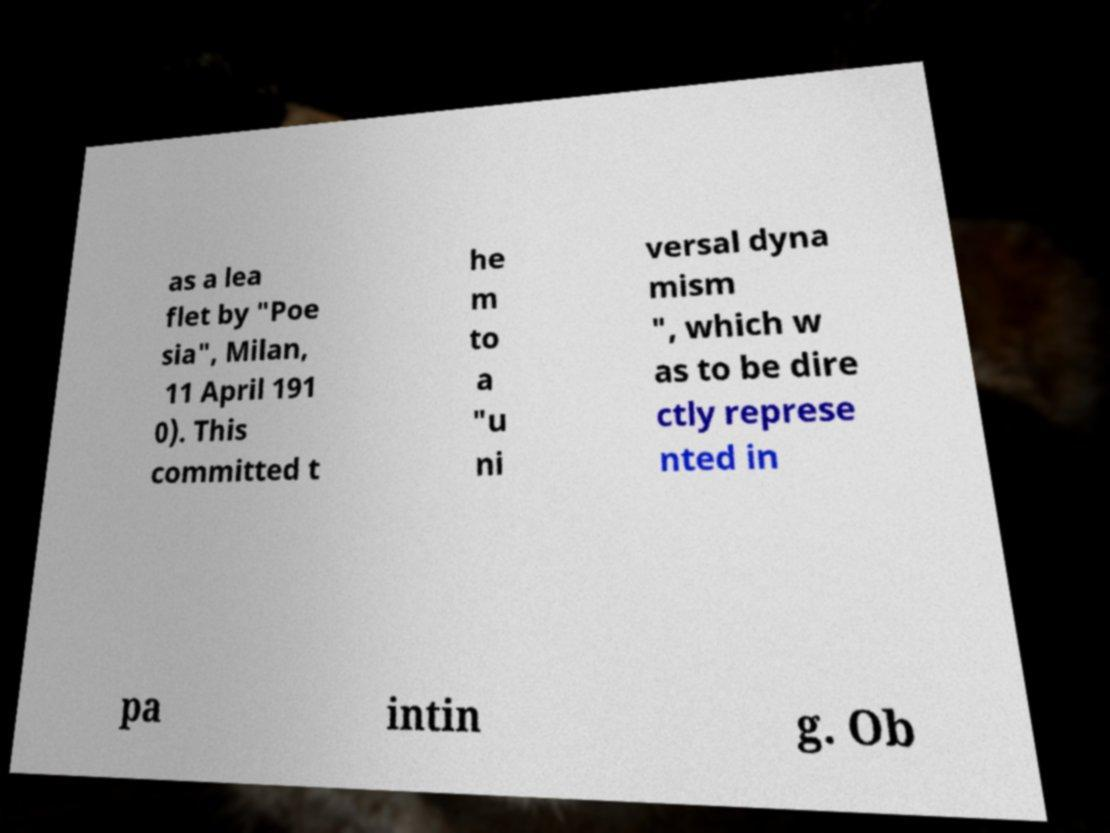Can you accurately transcribe the text from the provided image for me? as a lea flet by "Poe sia", Milan, 11 April 191 0). This committed t he m to a "u ni versal dyna mism ", which w as to be dire ctly represe nted in pa intin g. Ob 